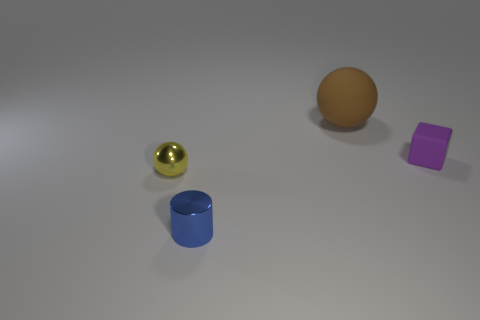There is a brown matte thing; is its shape the same as the tiny metal object left of the blue cylinder?
Your response must be concise. Yes. There is a cylinder that is the same size as the yellow sphere; what is its material?
Offer a very short reply. Metal. What shape is the object that is right of the tiny blue cylinder and in front of the matte sphere?
Provide a succinct answer. Cube. How many big brown spheres have the same material as the cylinder?
Ensure brevity in your answer.  0. Are there fewer tiny blue metallic things that are behind the blue shiny thing than big brown objects that are on the left side of the small purple matte object?
Give a very brief answer. Yes. What is the ball that is behind the matte object that is in front of the matte thing that is left of the tiny rubber cube made of?
Provide a succinct answer. Rubber. There is a thing that is both in front of the purple matte cube and on the right side of the yellow metallic sphere; what is its size?
Offer a terse response. Small. How many cylinders are either purple things or large brown things?
Your response must be concise. 0. There is a shiny ball that is the same size as the block; what is its color?
Keep it short and to the point. Yellow. Is there any other thing that has the same shape as the tiny yellow object?
Offer a terse response. Yes. 